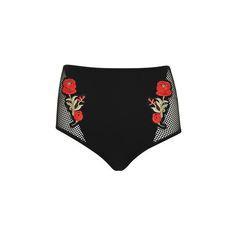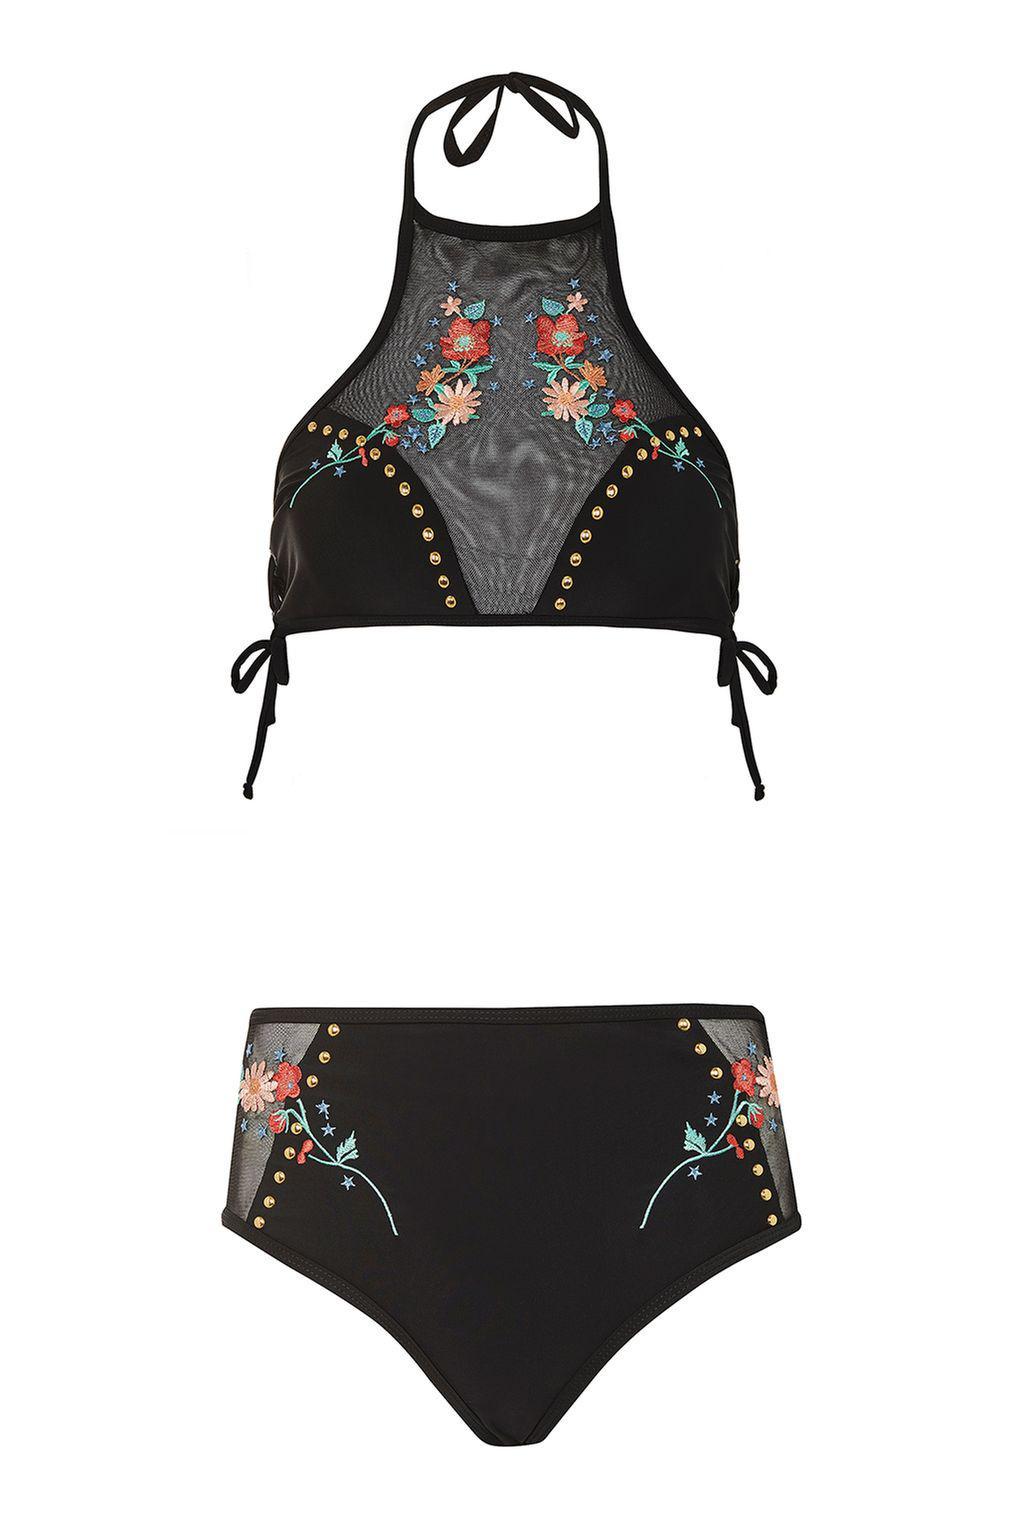The first image is the image on the left, the second image is the image on the right. Examine the images to the left and right. Is the description "the bathing suit in one of the images features a tie on bikini top." accurate? Answer yes or no. Yes. 